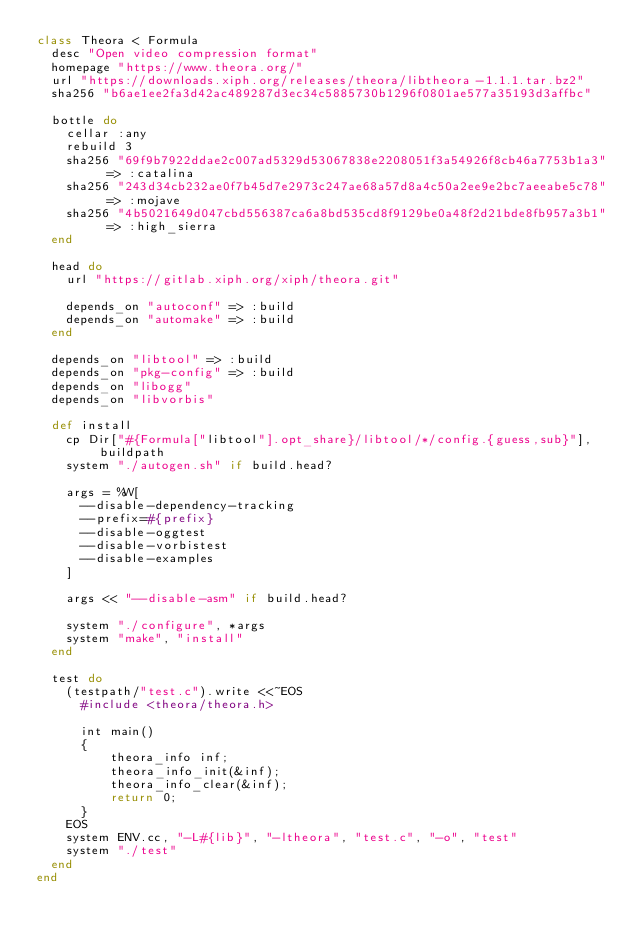Convert code to text. <code><loc_0><loc_0><loc_500><loc_500><_Ruby_>class Theora < Formula
  desc "Open video compression format"
  homepage "https://www.theora.org/"
  url "https://downloads.xiph.org/releases/theora/libtheora-1.1.1.tar.bz2"
  sha256 "b6ae1ee2fa3d42ac489287d3ec34c5885730b1296f0801ae577a35193d3affbc"

  bottle do
    cellar :any
    rebuild 3
    sha256 "69f9b7922ddae2c007ad5329d53067838e2208051f3a54926f8cb46a7753b1a3" => :catalina
    sha256 "243d34cb232ae0f7b45d7e2973c247ae68a57d8a4c50a2ee9e2bc7aeeabe5c78" => :mojave
    sha256 "4b5021649d047cbd556387ca6a8bd535cd8f9129be0a48f2d21bde8fb957a3b1" => :high_sierra
  end

  head do
    url "https://gitlab.xiph.org/xiph/theora.git"

    depends_on "autoconf" => :build
    depends_on "automake" => :build
  end

  depends_on "libtool" => :build
  depends_on "pkg-config" => :build
  depends_on "libogg"
  depends_on "libvorbis"

  def install
    cp Dir["#{Formula["libtool"].opt_share}/libtool/*/config.{guess,sub}"], buildpath
    system "./autogen.sh" if build.head?

    args = %W[
      --disable-dependency-tracking
      --prefix=#{prefix}
      --disable-oggtest
      --disable-vorbistest
      --disable-examples
    ]

    args << "--disable-asm" if build.head?

    system "./configure", *args
    system "make", "install"
  end

  test do
    (testpath/"test.c").write <<~EOS
      #include <theora/theora.h>

      int main()
      {
          theora_info inf;
          theora_info_init(&inf);
          theora_info_clear(&inf);
          return 0;
      }
    EOS
    system ENV.cc, "-L#{lib}", "-ltheora", "test.c", "-o", "test"
    system "./test"
  end
end
</code> 